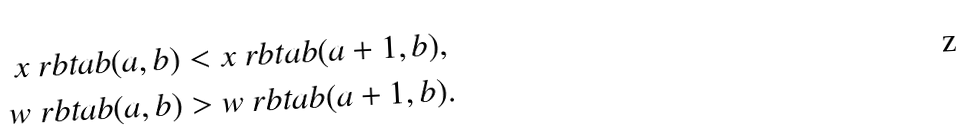<formula> <loc_0><loc_0><loc_500><loc_500>x { \ r b t a b } ( a , b ) & < x { \ r b t a b } ( a + 1 , b ) , \\ w { \ r b t a b } ( a , b ) & > w { \ r b t a b } ( a + 1 , b ) .</formula> 